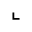Convert formula to latex. <formula><loc_0><loc_0><loc_500><loc_500>\llcorner</formula> 